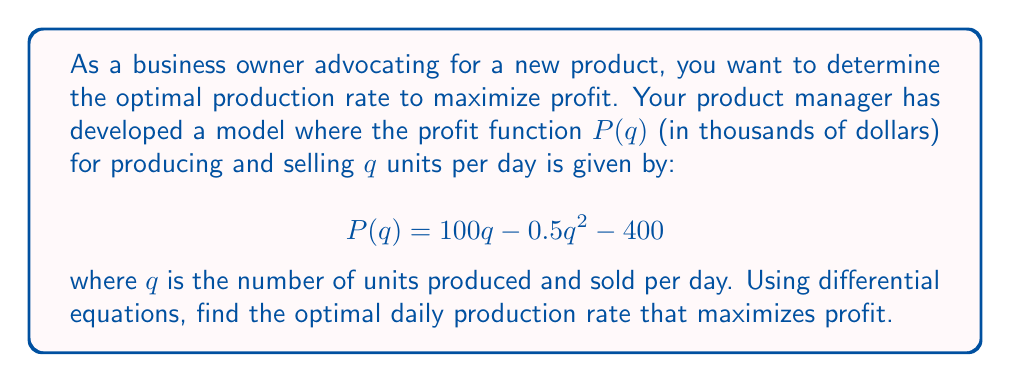Provide a solution to this math problem. To find the optimal production rate that maximizes profit, we need to follow these steps:

1) The profit function is given by:
   $$P(q) = 100q - 0.5q^2 - 400$$

2) To find the maximum profit, we need to find the value of $q$ where the derivative of $P(q)$ equals zero. Let's call this derivative $P'(q)$.

3) Calculate $P'(q)$ using the power rule:
   $$P'(q) = 100 - q$$

4) Set $P'(q) = 0$ and solve for $q$:
   $$100 - q = 0$$
   $$q = 100$$

5) To confirm this is a maximum (not a minimum), we can check the second derivative:
   $$P''(q) = -1$$
   Since $P''(q)$ is negative, we confirm that $q = 100$ gives a maximum.

6) Therefore, the optimal daily production rate is 100 units.

7) We can calculate the maximum profit by plugging $q = 100$ into the original profit function:
   $$P(100) = 100(100) - 0.5(100)^2 - 400$$
   $$= 10000 - 5000 - 400 = 4600$$

So, the maximum profit is $4,600,000 per day.
Answer: 100 units per day 